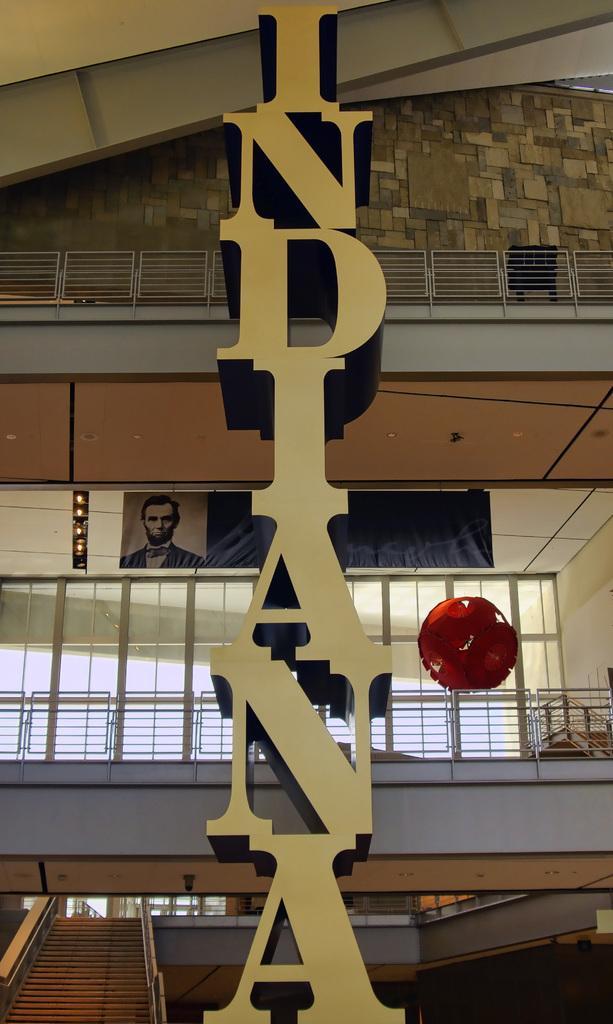Please provide a concise description of this image. In the center of the picture there is a hoarding. In the background there are railings, banners, staircase and glass windows.. 